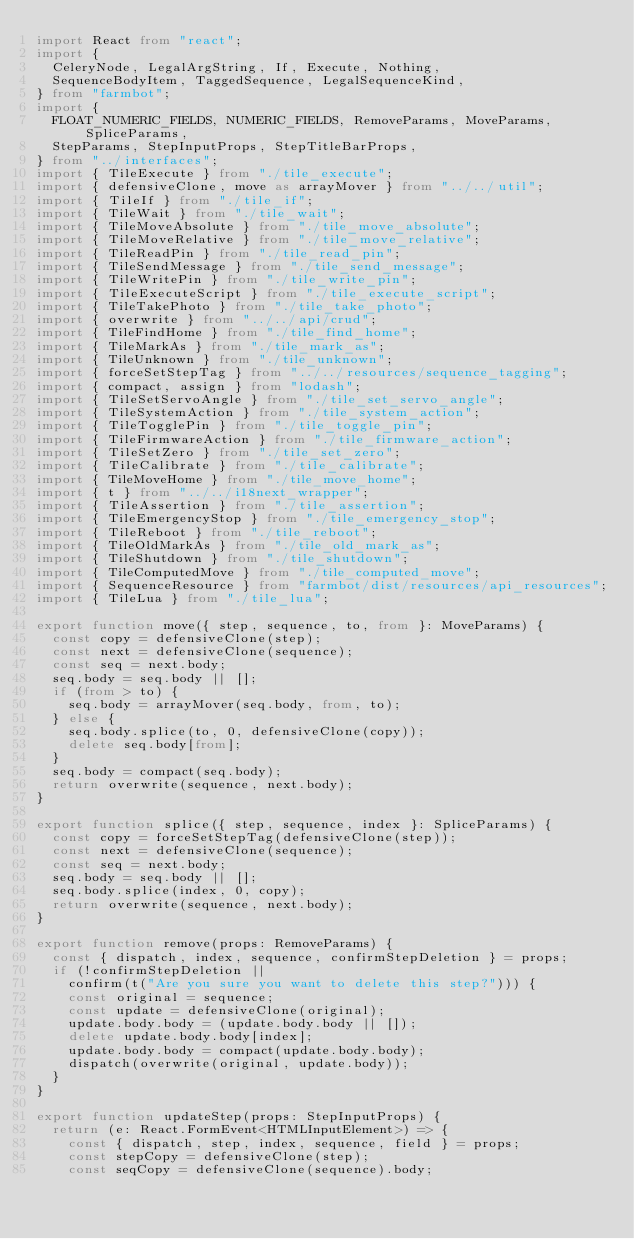<code> <loc_0><loc_0><loc_500><loc_500><_TypeScript_>import React from "react";
import {
  CeleryNode, LegalArgString, If, Execute, Nothing,
  SequenceBodyItem, TaggedSequence, LegalSequenceKind,
} from "farmbot";
import {
  FLOAT_NUMERIC_FIELDS, NUMERIC_FIELDS, RemoveParams, MoveParams, SpliceParams,
  StepParams, StepInputProps, StepTitleBarProps,
} from "../interfaces";
import { TileExecute } from "./tile_execute";
import { defensiveClone, move as arrayMover } from "../../util";
import { TileIf } from "./tile_if";
import { TileWait } from "./tile_wait";
import { TileMoveAbsolute } from "./tile_move_absolute";
import { TileMoveRelative } from "./tile_move_relative";
import { TileReadPin } from "./tile_read_pin";
import { TileSendMessage } from "./tile_send_message";
import { TileWritePin } from "./tile_write_pin";
import { TileExecuteScript } from "./tile_execute_script";
import { TileTakePhoto } from "./tile_take_photo";
import { overwrite } from "../../api/crud";
import { TileFindHome } from "./tile_find_home";
import { TileMarkAs } from "./tile_mark_as";
import { TileUnknown } from "./tile_unknown";
import { forceSetStepTag } from "../../resources/sequence_tagging";
import { compact, assign } from "lodash";
import { TileSetServoAngle } from "./tile_set_servo_angle";
import { TileSystemAction } from "./tile_system_action";
import { TileTogglePin } from "./tile_toggle_pin";
import { TileFirmwareAction } from "./tile_firmware_action";
import { TileSetZero } from "./tile_set_zero";
import { TileCalibrate } from "./tile_calibrate";
import { TileMoveHome } from "./tile_move_home";
import { t } from "../../i18next_wrapper";
import { TileAssertion } from "./tile_assertion";
import { TileEmergencyStop } from "./tile_emergency_stop";
import { TileReboot } from "./tile_reboot";
import { TileOldMarkAs } from "./tile_old_mark_as";
import { TileShutdown } from "./tile_shutdown";
import { TileComputedMove } from "./tile_computed_move";
import { SequenceResource } from "farmbot/dist/resources/api_resources";
import { TileLua } from "./tile_lua";

export function move({ step, sequence, to, from }: MoveParams) {
  const copy = defensiveClone(step);
  const next = defensiveClone(sequence);
  const seq = next.body;
  seq.body = seq.body || [];
  if (from > to) {
    seq.body = arrayMover(seq.body, from, to);
  } else {
    seq.body.splice(to, 0, defensiveClone(copy));
    delete seq.body[from];
  }
  seq.body = compact(seq.body);
  return overwrite(sequence, next.body);
}

export function splice({ step, sequence, index }: SpliceParams) {
  const copy = forceSetStepTag(defensiveClone(step));
  const next = defensiveClone(sequence);
  const seq = next.body;
  seq.body = seq.body || [];
  seq.body.splice(index, 0, copy);
  return overwrite(sequence, next.body);
}

export function remove(props: RemoveParams) {
  const { dispatch, index, sequence, confirmStepDeletion } = props;
  if (!confirmStepDeletion ||
    confirm(t("Are you sure you want to delete this step?"))) {
    const original = sequence;
    const update = defensiveClone(original);
    update.body.body = (update.body.body || []);
    delete update.body.body[index];
    update.body.body = compact(update.body.body);
    dispatch(overwrite(original, update.body));
  }
}

export function updateStep(props: StepInputProps) {
  return (e: React.FormEvent<HTMLInputElement>) => {
    const { dispatch, step, index, sequence, field } = props;
    const stepCopy = defensiveClone(step);
    const seqCopy = defensiveClone(sequence).body;</code> 